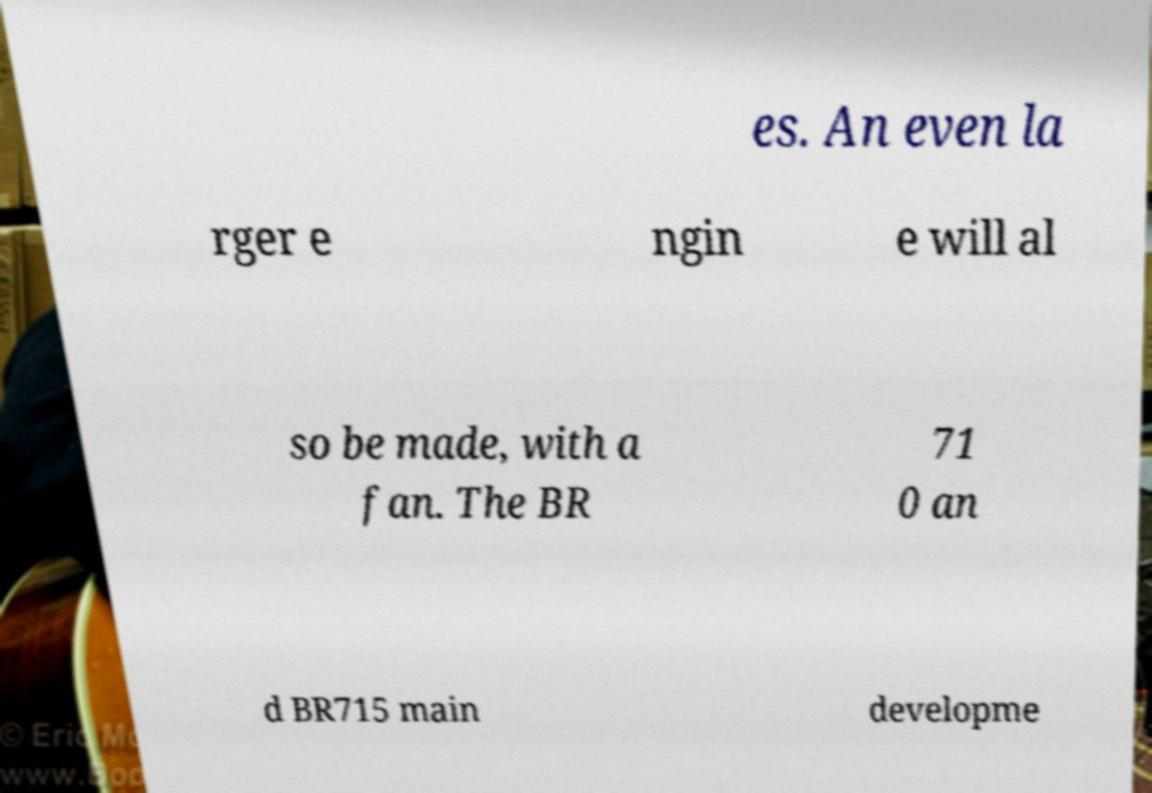Can you accurately transcribe the text from the provided image for me? es. An even la rger e ngin e will al so be made, with a fan. The BR 71 0 an d BR715 main developme 